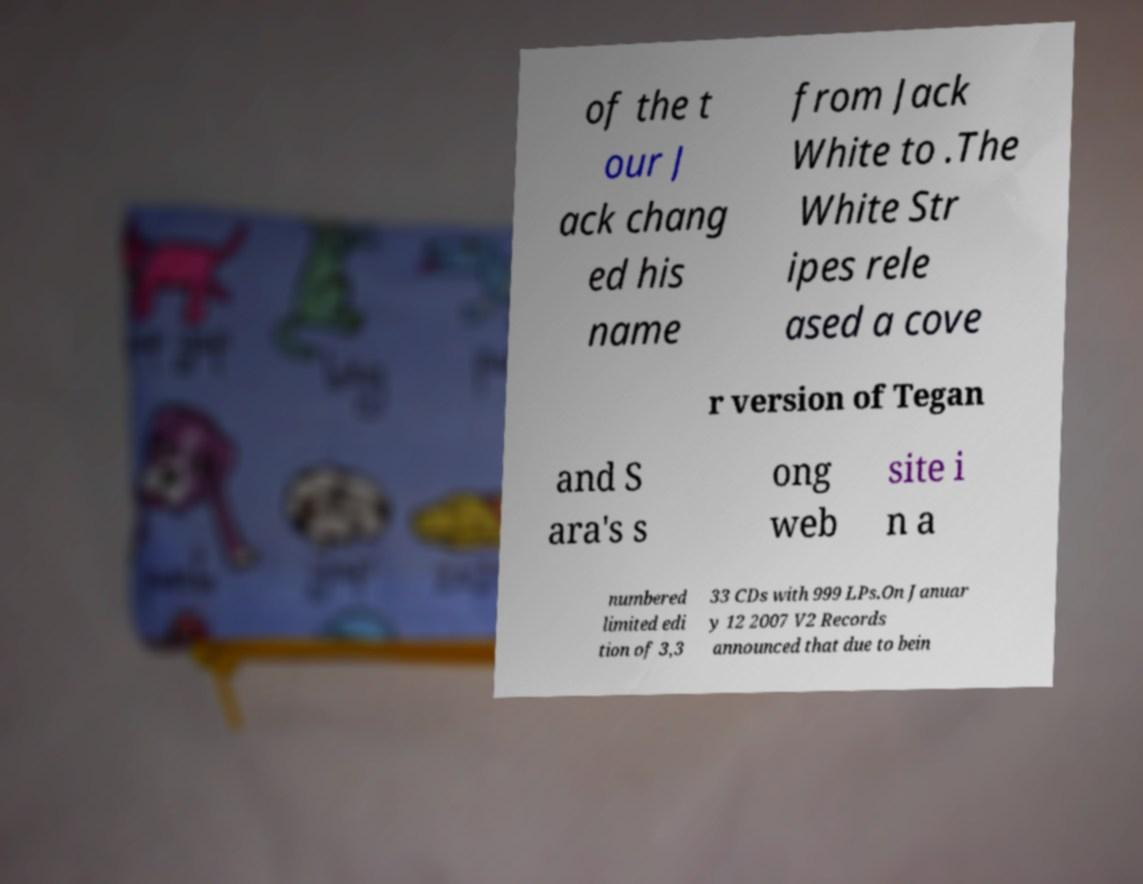What messages or text are displayed in this image? I need them in a readable, typed format. of the t our J ack chang ed his name from Jack White to .The White Str ipes rele ased a cove r version of Tegan and S ara's s ong web site i n a numbered limited edi tion of 3,3 33 CDs with 999 LPs.On Januar y 12 2007 V2 Records announced that due to bein 